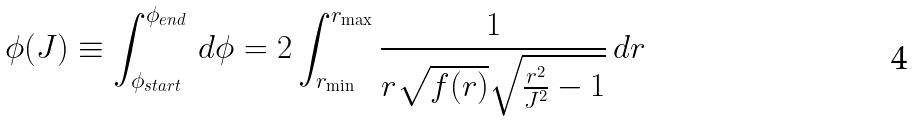Convert formula to latex. <formula><loc_0><loc_0><loc_500><loc_500>\phi ( J ) \equiv \int _ { \phi _ { s t a r t } } ^ { \phi _ { e n d } } \, d \phi = 2 \int _ { r _ { \min } } ^ { r _ { \max } } \frac { 1 } { r \sqrt { f ( r ) } \sqrt { \frac { r ^ { 2 } } { J ^ { 2 } } - 1 } } \, d r</formula> 